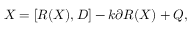Convert formula to latex. <formula><loc_0><loc_0><loc_500><loc_500>X = [ R ( X ) , D ] - k \partial R ( X ) + Q ,</formula> 